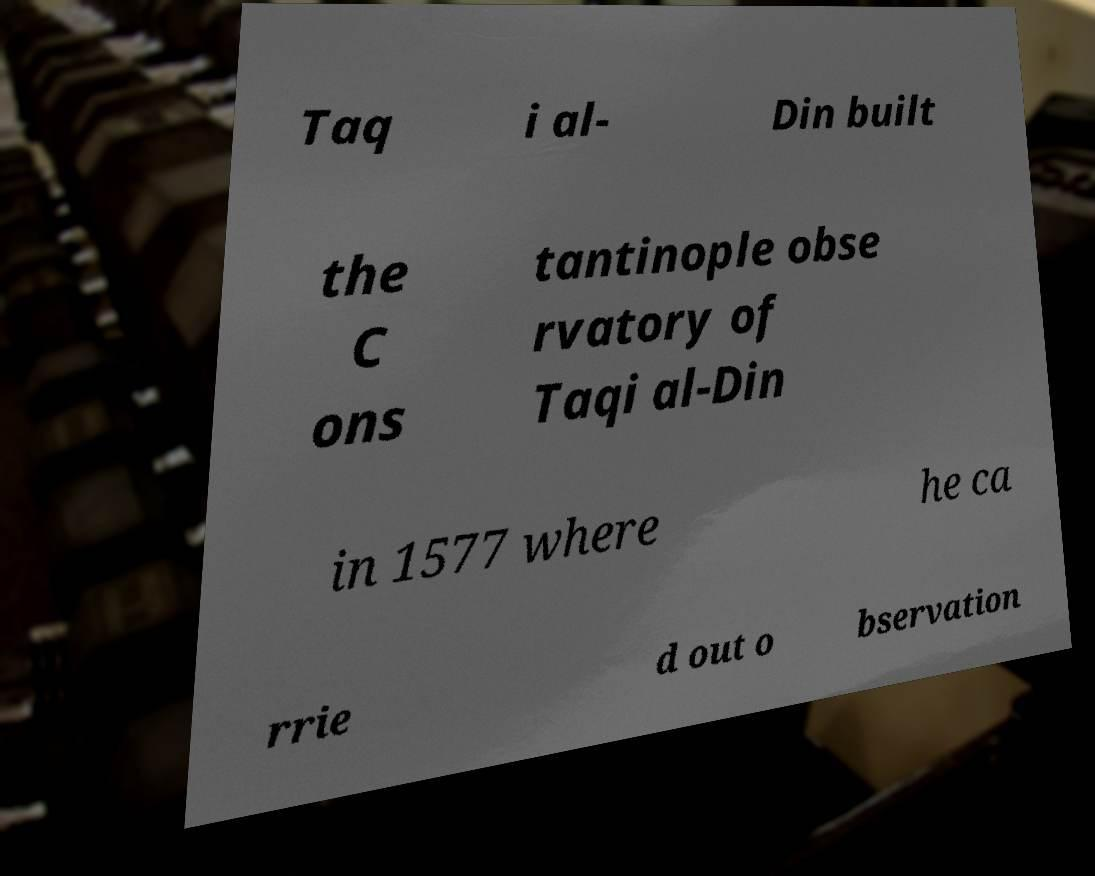What messages or text are displayed in this image? I need them in a readable, typed format. Taq i al- Din built the C ons tantinople obse rvatory of Taqi al-Din in 1577 where he ca rrie d out o bservation 